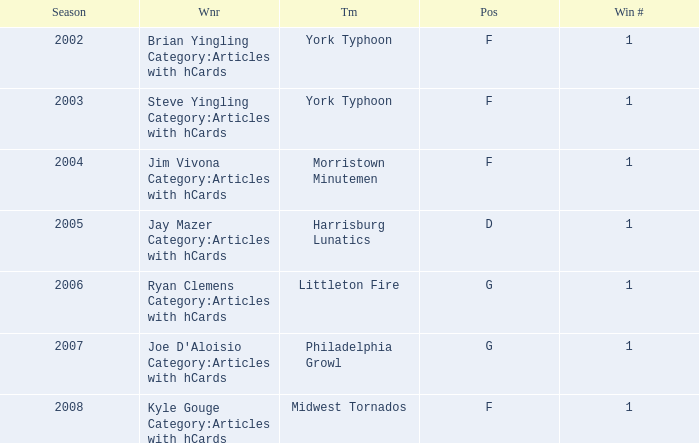Who was the winner in the 2008 season? Kyle Gouge Category:Articles with hCards. 